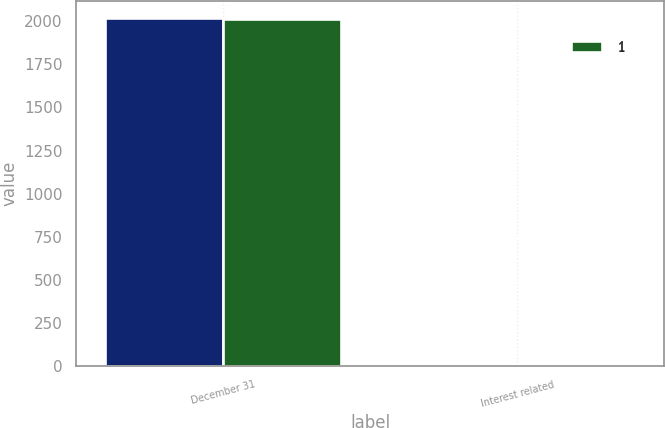<chart> <loc_0><loc_0><loc_500><loc_500><stacked_bar_chart><ecel><fcel>December 31<fcel>Interest related<nl><fcel>nan<fcel>2016<fcel>10<nl><fcel>1<fcel>2015<fcel>8<nl></chart> 